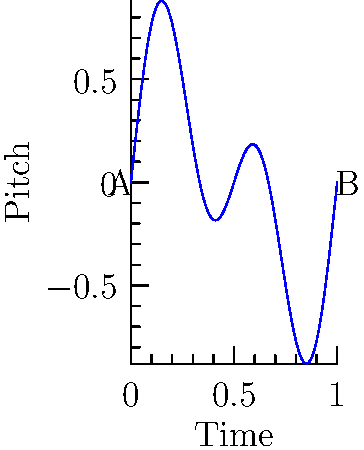In the context of vocal performance analysis, consider the pitch transition curve shown above. If this represents a singer's pitch over time during a musical phrase, at which point(s) would the transition be considered discontinuous in terms of topology? To analyze the continuity of the pitch transition, we need to examine the curve for any breaks, jumps, or sudden changes. Here's a step-by-step explanation:

1. Observe the overall shape of the curve: The graph shows a smooth, continuous wave-like pattern from point A to point B.

2. Check for discontinuities:
   a) A function is discontinuous if there are any breaks or jumps in the curve.
   b) In this case, the curve is unbroken from start to finish.

3. Examine endpoints:
   a) Point A (start) and Point B (end) are connected by the continuous curve.
   b) There are no sudden jumps or gaps at these points.

4. Analyze smoothness:
   a) The curve appears to be smooth throughout, with no sharp corners or abrupt changes in direction.
   b) This suggests that not only is the function continuous, but it's also differentiable.

5. Consider the musical context:
   a) In vocal performance, this smooth curve would represent a seamless transition between pitches.
   b) The waviness suggests vibrato or intentional pitch modulation, which is common in singing.

6. Topological continuity:
   a) In topology, a function is continuous if it doesn't have any "breaks" or "jumps".
   b) This curve satisfies the topological definition of continuity.

Given these observations, we can conclude that there are no points of discontinuity in this pitch transition curve. The transition is continuous throughout the entire musical phrase represented by the graph.
Answer: None 